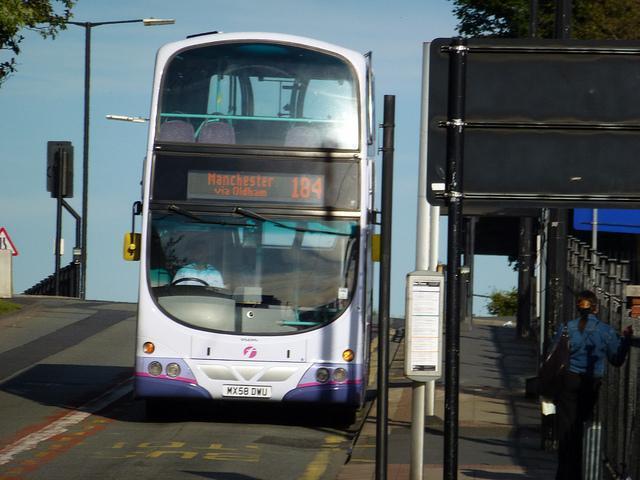How many levels does this bus have?
Give a very brief answer. 2. How many buses are visible?
Give a very brief answer. 1. 